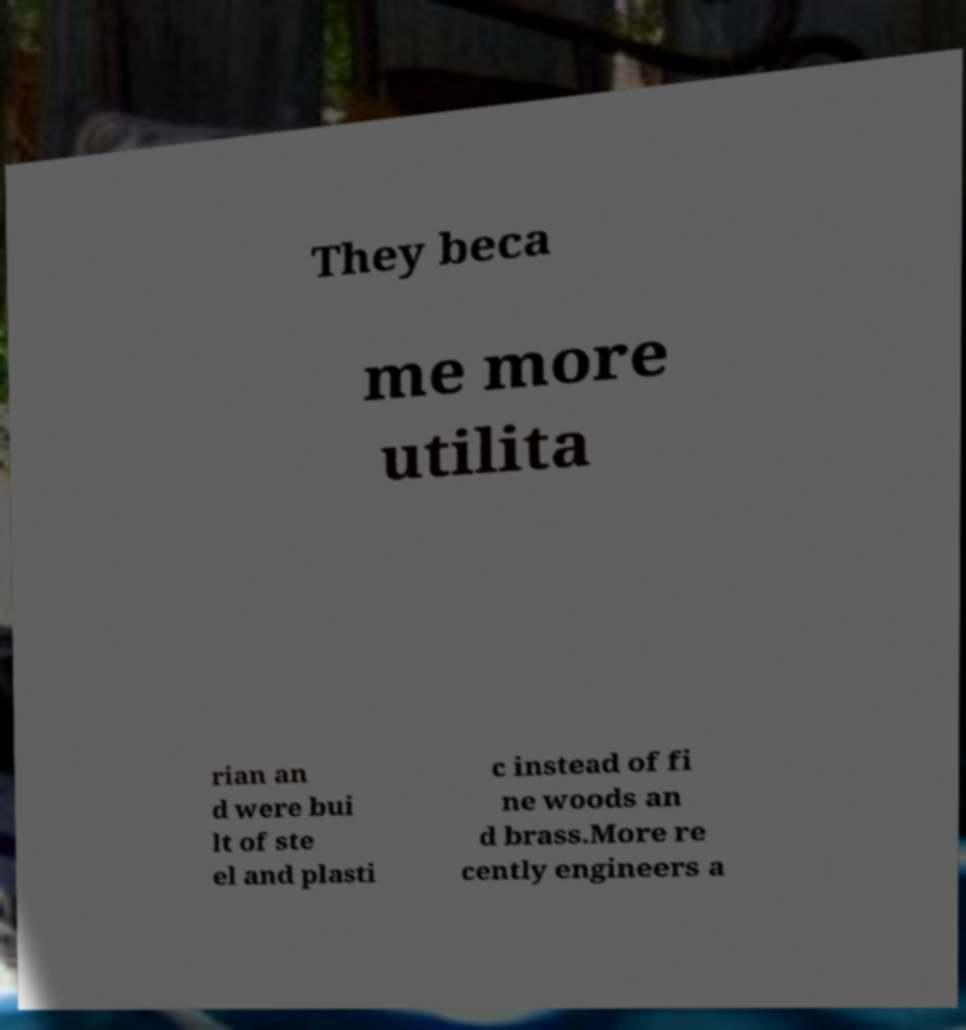What messages or text are displayed in this image? I need them in a readable, typed format. They beca me more utilita rian an d were bui lt of ste el and plasti c instead of fi ne woods an d brass.More re cently engineers a 